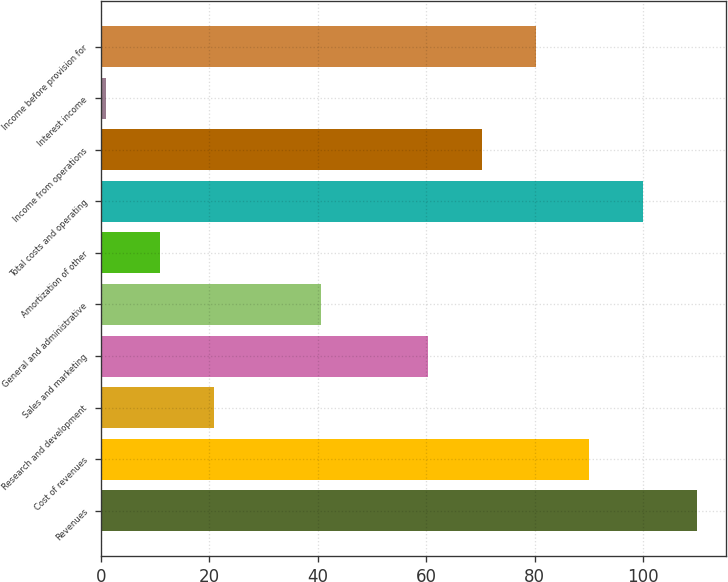<chart> <loc_0><loc_0><loc_500><loc_500><bar_chart><fcel>Revenues<fcel>Cost of revenues<fcel>Research and development<fcel>Sales and marketing<fcel>General and administrative<fcel>Amortization of other<fcel>Total costs and operating<fcel>Income from operations<fcel>Interest income<fcel>Income before provision for<nl><fcel>109.9<fcel>90.1<fcel>20.8<fcel>60.4<fcel>40.6<fcel>10.9<fcel>100<fcel>70.3<fcel>1<fcel>80.2<nl></chart> 